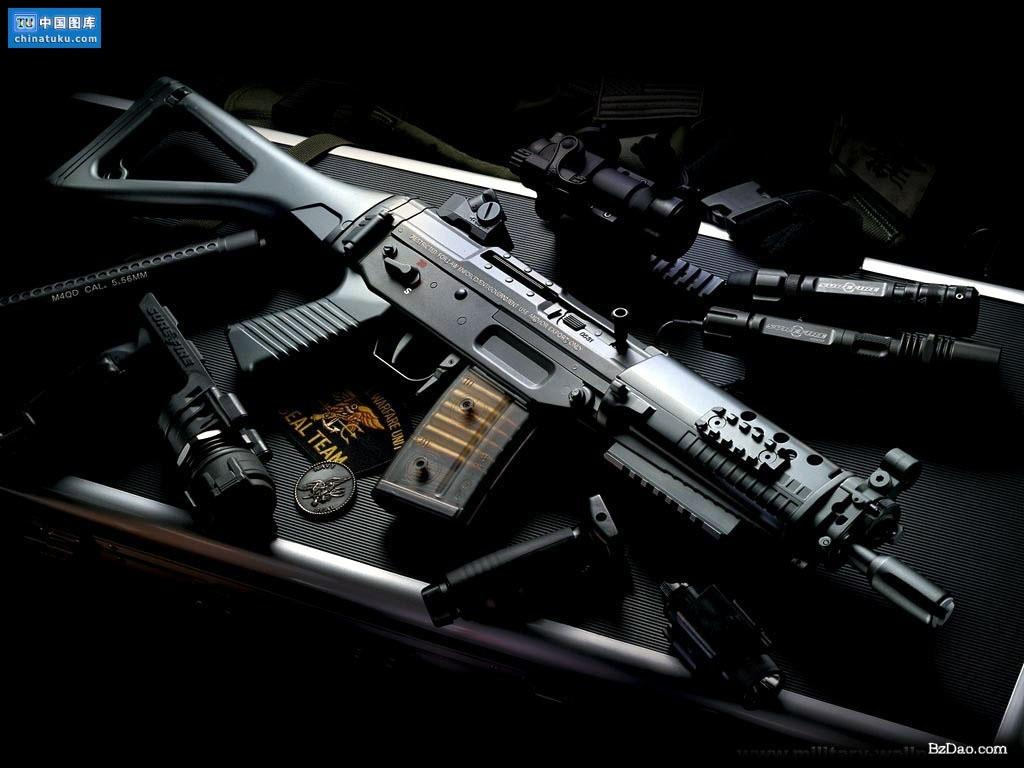What type of objects can be seen in the image? There are weapons in the image. What is the color of the surface where the weapons are placed? The surface is black in color. What type of car is visible in the image? There is no car present in the image; it only features weapons on a black surface. What time of day is it in the image? The time of day is not mentioned or depicted in the image, so it cannot be determined. 